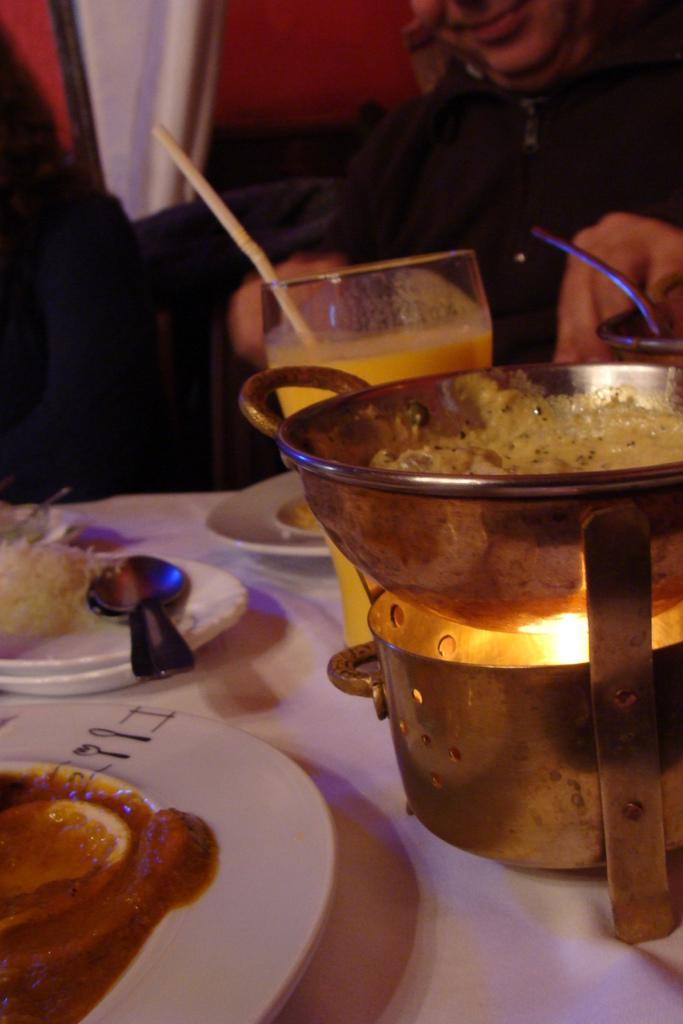What type of utensils can be seen in the image? There are spoons in the image. What is contained in a bowl in the image? There is food in a bowl in the image. What type of beverage is in a glass in the image? There is juice in a glass in the image. What is used to drink the juice in the image? There is a straw in the image. What is the source of heat in the image? There is fire in the image. What is the color of the background behind the person in the image? There is a red background behind a person in the image. What type of fuel is being used to power the noise in the image? There is no reference to fuel or noise in the image; it features plates, spoons, a bowl of food, a glass of juice, a straw, fire, and a red background behind a person. 